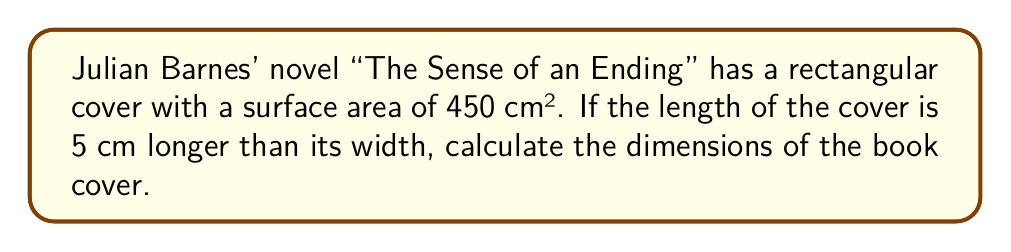What is the answer to this math problem? Let's approach this step-by-step:

1) Let's define our variables:
   $w$ = width of the cover
   $l$ = length of the cover

2) We're told that the length is 5 cm longer than the width:
   $l = w + 5$

3) We know that the area of a rectangle is length times width:
   $A = l * w$

4) We're given that the area is 450 cm²:
   $450 = l * w$

5) Substituting the expression for $l$ from step 2:
   $450 = (w + 5) * w$

6) Expand this equation:
   $450 = w^2 + 5w$

7) Rearrange to standard quadratic form:
   $w^2 + 5w - 450 = 0$

8) We can solve this using the quadratic formula: $\frac{-b \pm \sqrt{b^2 - 4ac}}{2a}$
   Where $a = 1$, $b = 5$, and $c = -450$

9) Plugging into the quadratic formula:
   $$w = \frac{-5 \pm \sqrt{5^2 - 4(1)(-450)}}{2(1)} = \frac{-5 \pm \sqrt{1825}}{2}$$

10) Simplify:
    $$w = \frac{-5 \pm 42.72}{2}$$

11) This gives us two solutions:
    $w = 18.86$ cm or $w = -23.86$ cm

12) Since width can't be negative, we take the positive solution:
    $w = 18.86$ cm

13) To find the length, we use the equation from step 2:
    $l = 18.86 + 5 = 23.86$ cm

Therefore, the dimensions of the book cover are approximately 18.86 cm x 23.86 cm.
Answer: The dimensions of the book cover are approximately 18.86 cm wide and 23.86 cm long. 